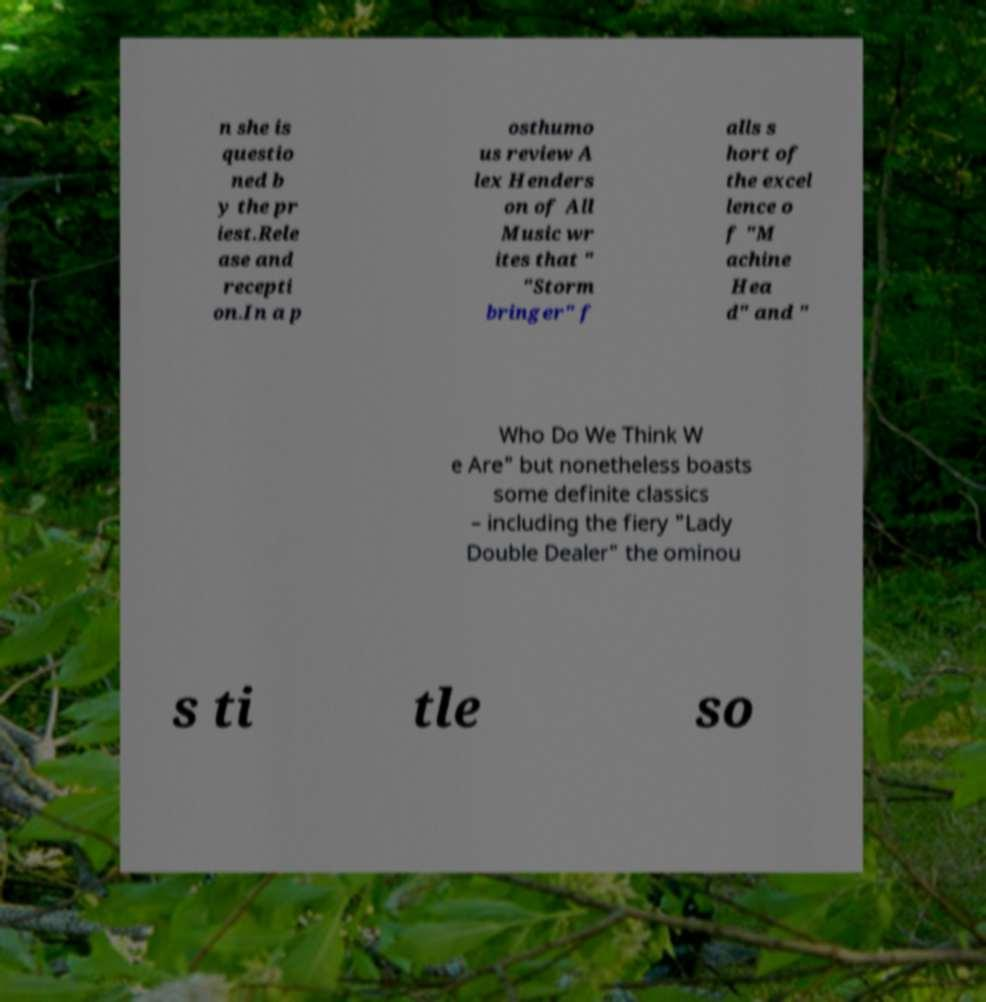Please identify and transcribe the text found in this image. n she is questio ned b y the pr iest.Rele ase and recepti on.In a p osthumo us review A lex Henders on of All Music wr ites that " "Storm bringer" f alls s hort of the excel lence o f "M achine Hea d" and " Who Do We Think W e Are" but nonetheless boasts some definite classics – including the fiery "Lady Double Dealer" the ominou s ti tle so 